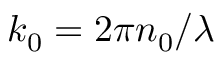Convert formula to latex. <formula><loc_0><loc_0><loc_500><loc_500>k _ { 0 } = 2 \pi n _ { 0 } / \lambda</formula> 